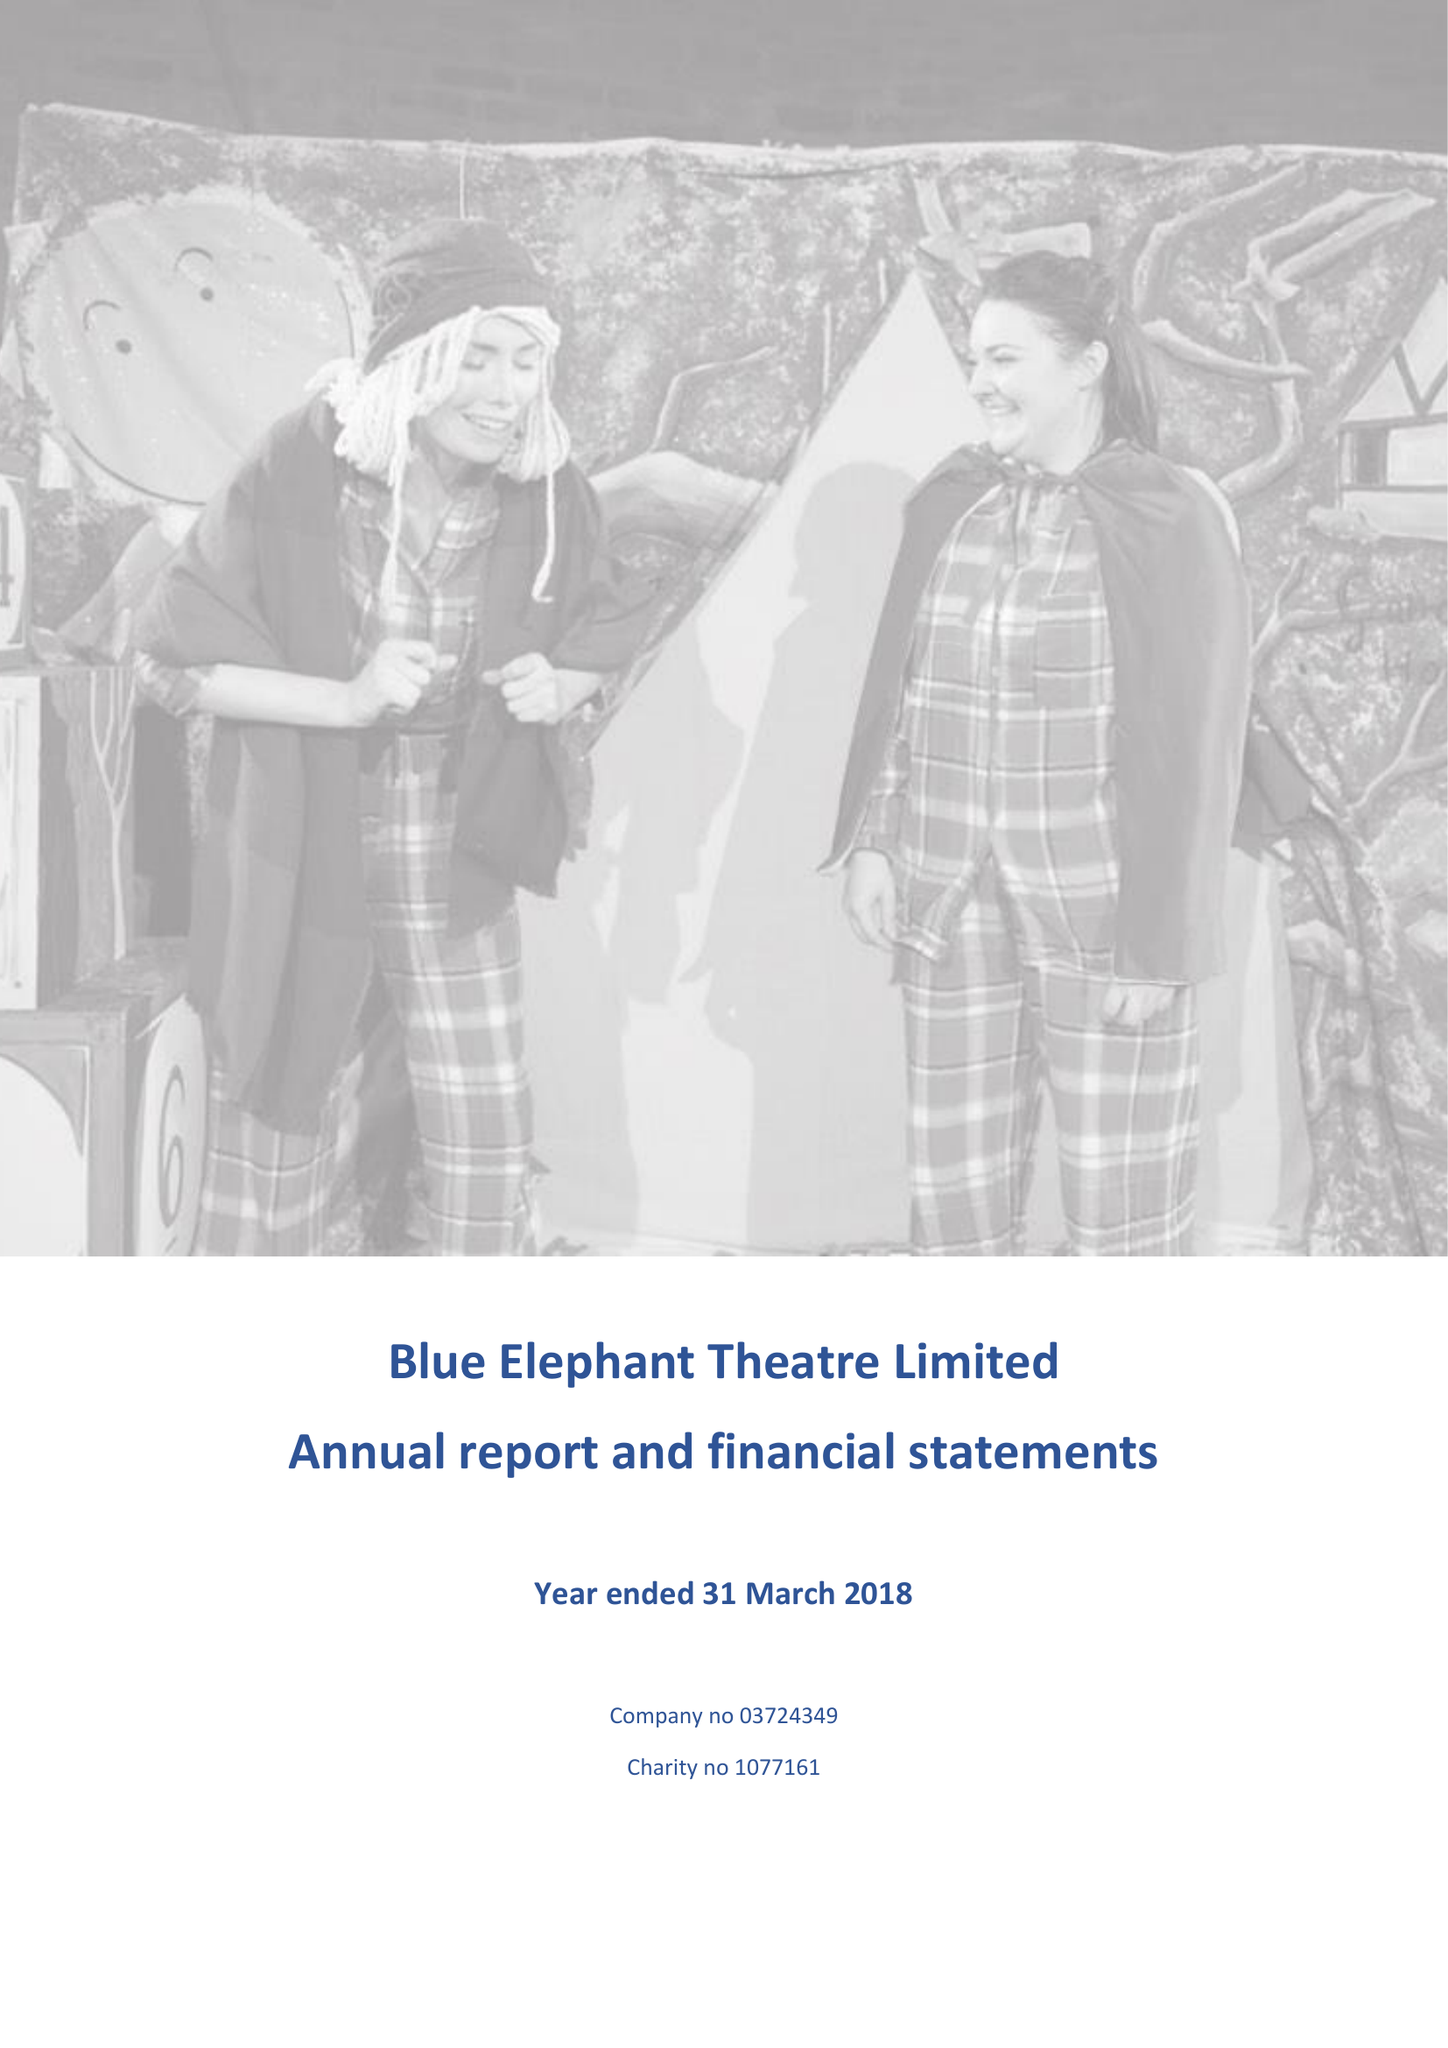What is the value for the address__post_town?
Answer the question using a single word or phrase. LONDON 